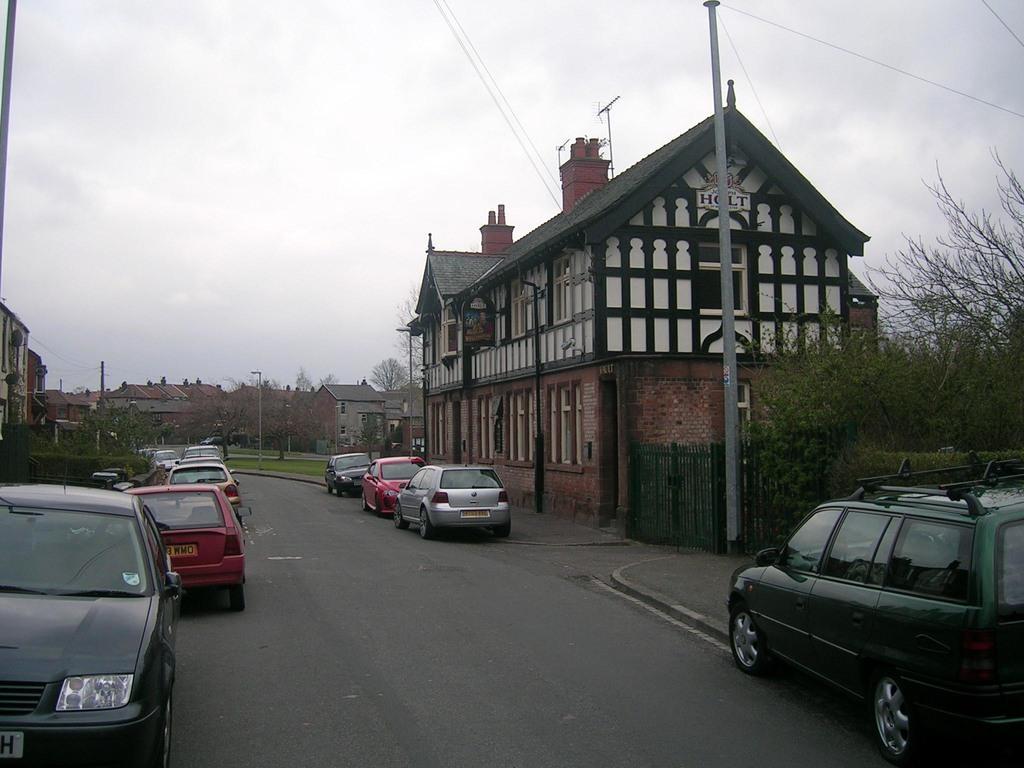Could you give a brief overview of what you see in this image? In this image there is a road on which there are so many cars. On the right side there is a building beside the road. On the footpath there are poles. At the top there is sky. In the background there are buildings and houses. On the right side there are trees. 